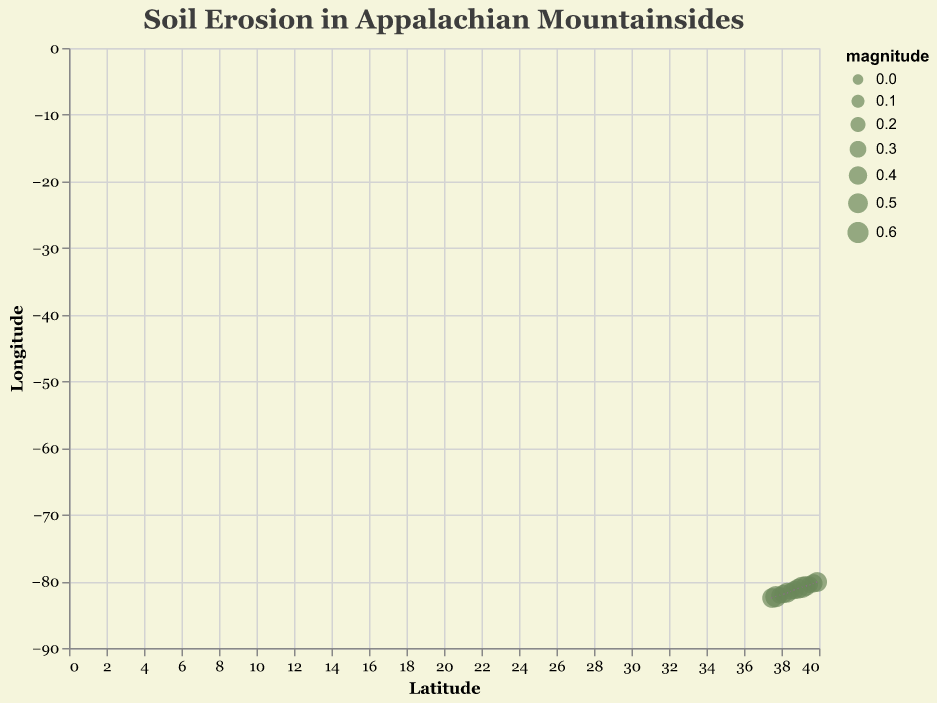What is the title of the plot? The title is usually presented prominently at the top of the figure, often with larger font size. In this plot, the title is displayed as "Soil Erosion in Appalachian Mountainsides".
Answer: Soil Erosion in Appalachian Mountainsides What do the axes represent? The axes labels usually describe what each axis is measuring. Here, the x-axis represents "Latitude" and the y-axis represents "Longitude".
Answer: Latitude and Longitude What do the different colors of the arrows indicate? In this particular plot, all arrows are the same color, so the color doesn't indicate any difference between the data points.
Answer: All arrows are the same color How many data points are represented in the plot? Each arrow and associated point on the plot represents a data point. Counting them up gives you the total number of data points.
Answer: 13 What is the direction of soil movement at (37.5, -82.5)? The direction can be determined by examining the arrow's vector. For the point at (37.5, -82.5), the arrow points from (-0.2, 0.3) indicating movement in the upward and slightly leftward direction.
Answer: Upward and slightly leftward Which data point shows the highest magnitude of soil movement? Magnitude is indicated by the size of the point on the plot. The larger the point, the greater the magnitude. The point at (39.1, -80.9) has the largest magnitude of 0.6.
Answer: (39.1, -80.9) Which region is experiencing downward soil erosion based on the plot? Downward erosion is indicated by arrows pointing downward on the y-axis. The data points at (38.1, -81.9), (38.3, -81.7), (38.5, -81.5), (39.5, -80.5), and (39.7, -80.3) have arrows pointing downward.
Answer: (38.1, -81.9), (38.3, -81.7), (38.5, -81.5), (39.5, -80.5), (39.7, -80.3) What is the general trend of soil movement direction across the latitude values? Observing the arrows' directions can reveal if there's a general trend. Most arrows show a combination of horizontal and vertical movement, with no consistent single direction across all latitudes.
Answer: Mixed horizontal and vertical movement How does the magnitude of soil movement change as we move from west to east longitudinally? Observing the size of the plotted points can provide insight. Moving from west (-82.5) to east (-80.1), magnitudes vary without a clear increasing or decreasing trend.
Answer: No clear trend Why might it be useful to know both the magnitude and direction of soil movement in this region? Understanding both magnitude and direction provides a comprehensive view of erosion patterns, which is crucial for environmental planning and conservation efforts in regions with varying topography like the Appalachian mountainsides.
Answer: Comprehensive view of erosion patterns for planning 